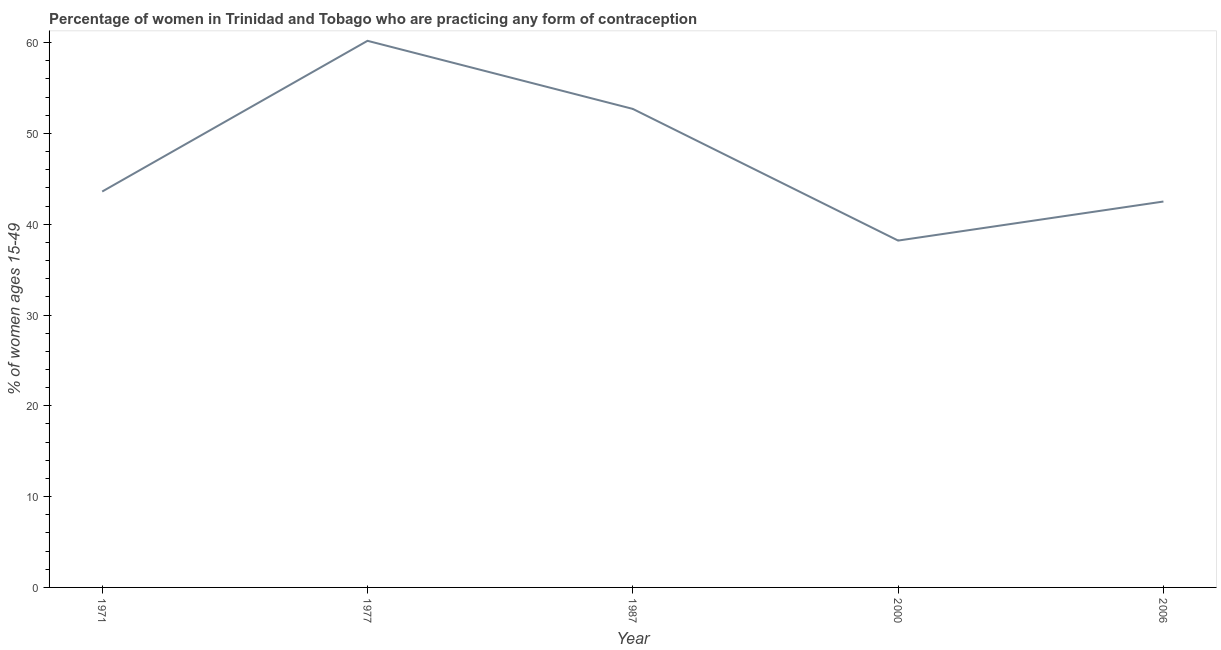What is the contraceptive prevalence in 1987?
Provide a succinct answer. 52.7. Across all years, what is the maximum contraceptive prevalence?
Your answer should be very brief. 60.2. Across all years, what is the minimum contraceptive prevalence?
Ensure brevity in your answer.  38.2. What is the sum of the contraceptive prevalence?
Give a very brief answer. 237.2. What is the difference between the contraceptive prevalence in 1971 and 2006?
Keep it short and to the point. 1.1. What is the average contraceptive prevalence per year?
Your answer should be very brief. 47.44. What is the median contraceptive prevalence?
Keep it short and to the point. 43.6. What is the ratio of the contraceptive prevalence in 1971 to that in 1977?
Make the answer very short. 0.72. Is the difference between the contraceptive prevalence in 1987 and 2000 greater than the difference between any two years?
Offer a terse response. No. What is the difference between the highest and the second highest contraceptive prevalence?
Provide a succinct answer. 7.5. What is the difference between the highest and the lowest contraceptive prevalence?
Give a very brief answer. 22. How many years are there in the graph?
Keep it short and to the point. 5. Does the graph contain any zero values?
Ensure brevity in your answer.  No. Does the graph contain grids?
Give a very brief answer. No. What is the title of the graph?
Keep it short and to the point. Percentage of women in Trinidad and Tobago who are practicing any form of contraception. What is the label or title of the Y-axis?
Offer a very short reply. % of women ages 15-49. What is the % of women ages 15-49 in 1971?
Ensure brevity in your answer.  43.6. What is the % of women ages 15-49 of 1977?
Ensure brevity in your answer.  60.2. What is the % of women ages 15-49 in 1987?
Offer a very short reply. 52.7. What is the % of women ages 15-49 of 2000?
Offer a terse response. 38.2. What is the % of women ages 15-49 in 2006?
Your answer should be compact. 42.5. What is the difference between the % of women ages 15-49 in 1971 and 1977?
Provide a short and direct response. -16.6. What is the difference between the % of women ages 15-49 in 1971 and 2000?
Make the answer very short. 5.4. What is the difference between the % of women ages 15-49 in 1977 and 2000?
Your answer should be compact. 22. What is the difference between the % of women ages 15-49 in 1977 and 2006?
Keep it short and to the point. 17.7. What is the difference between the % of women ages 15-49 in 2000 and 2006?
Offer a very short reply. -4.3. What is the ratio of the % of women ages 15-49 in 1971 to that in 1977?
Make the answer very short. 0.72. What is the ratio of the % of women ages 15-49 in 1971 to that in 1987?
Offer a terse response. 0.83. What is the ratio of the % of women ages 15-49 in 1971 to that in 2000?
Your response must be concise. 1.14. What is the ratio of the % of women ages 15-49 in 1971 to that in 2006?
Your response must be concise. 1.03. What is the ratio of the % of women ages 15-49 in 1977 to that in 1987?
Ensure brevity in your answer.  1.14. What is the ratio of the % of women ages 15-49 in 1977 to that in 2000?
Provide a short and direct response. 1.58. What is the ratio of the % of women ages 15-49 in 1977 to that in 2006?
Provide a short and direct response. 1.42. What is the ratio of the % of women ages 15-49 in 1987 to that in 2000?
Your answer should be very brief. 1.38. What is the ratio of the % of women ages 15-49 in 1987 to that in 2006?
Make the answer very short. 1.24. What is the ratio of the % of women ages 15-49 in 2000 to that in 2006?
Offer a terse response. 0.9. 